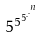Convert formula to latex. <formula><loc_0><loc_0><loc_500><loc_500>5 ^ { 5 ^ { 5 ^ { . ^ { . ^ { n } } } } }</formula> 